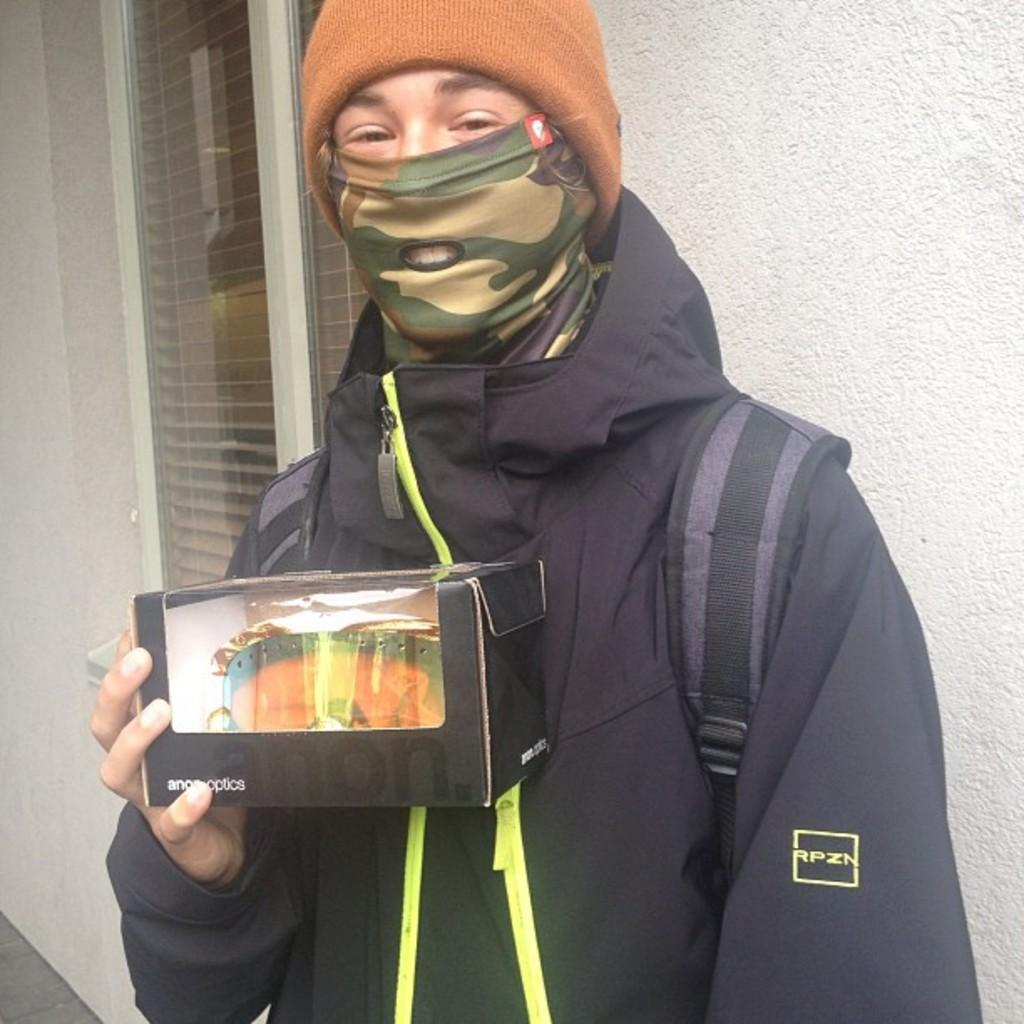What is the person in the image doing? The person is standing in the image. What is the person wearing? The person is wearing a black dress. What is the person holding in the image? The person is holding something. What can be seen in the background of the image? There are windows and a white wall visible in the background. Can you tell me how many goldfish are swimming in the image? There are no goldfish present in the image. What type of base is supporting the person in the image? The person is standing, so there is no base supporting them in the image. 